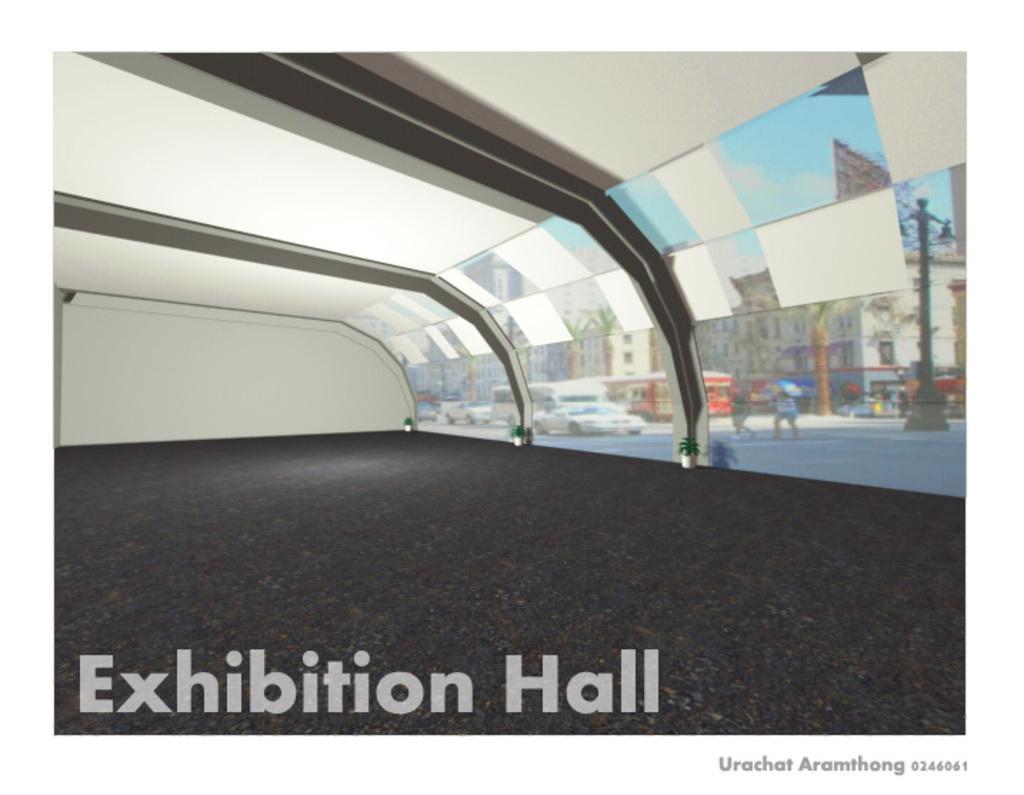Can you describe this image briefly? In this picture I can see the inside view of the exhibition hall. Through the glass partitions I can see the car, bus and other vehicles were running on the road. Beside them I can see the streetlights and building. On the right there are two persons who are crossing the road. beside them I can see the street lights. In the top right corner I can see the advertisement board, sky and clouds. At the bottom I can see the watermarks. 